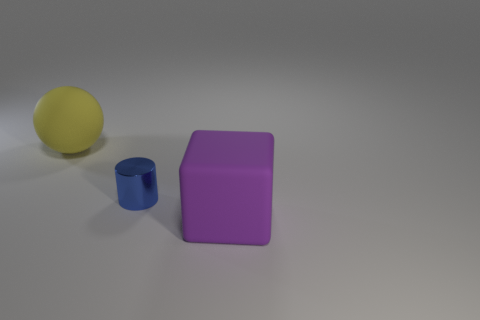Is there anything else that has the same shape as the small object?
Your answer should be compact. No. Are any tiny shiny things visible?
Offer a terse response. Yes. Do the sphere and the big purple thing have the same material?
Your answer should be very brief. Yes. What number of other things are made of the same material as the small thing?
Ensure brevity in your answer.  0. How many large objects are on the left side of the purple matte thing and on the right side of the yellow object?
Your answer should be very brief. 0. The large cube has what color?
Provide a succinct answer. Purple. Are there any other things that are the same material as the tiny cylinder?
Provide a succinct answer. No. The matte thing right of the matte thing behind the big matte cube is what shape?
Offer a terse response. Cube. The large thing that is the same material as the large block is what shape?
Provide a short and direct response. Sphere. What number of other things are the same shape as the yellow object?
Make the answer very short. 0. 